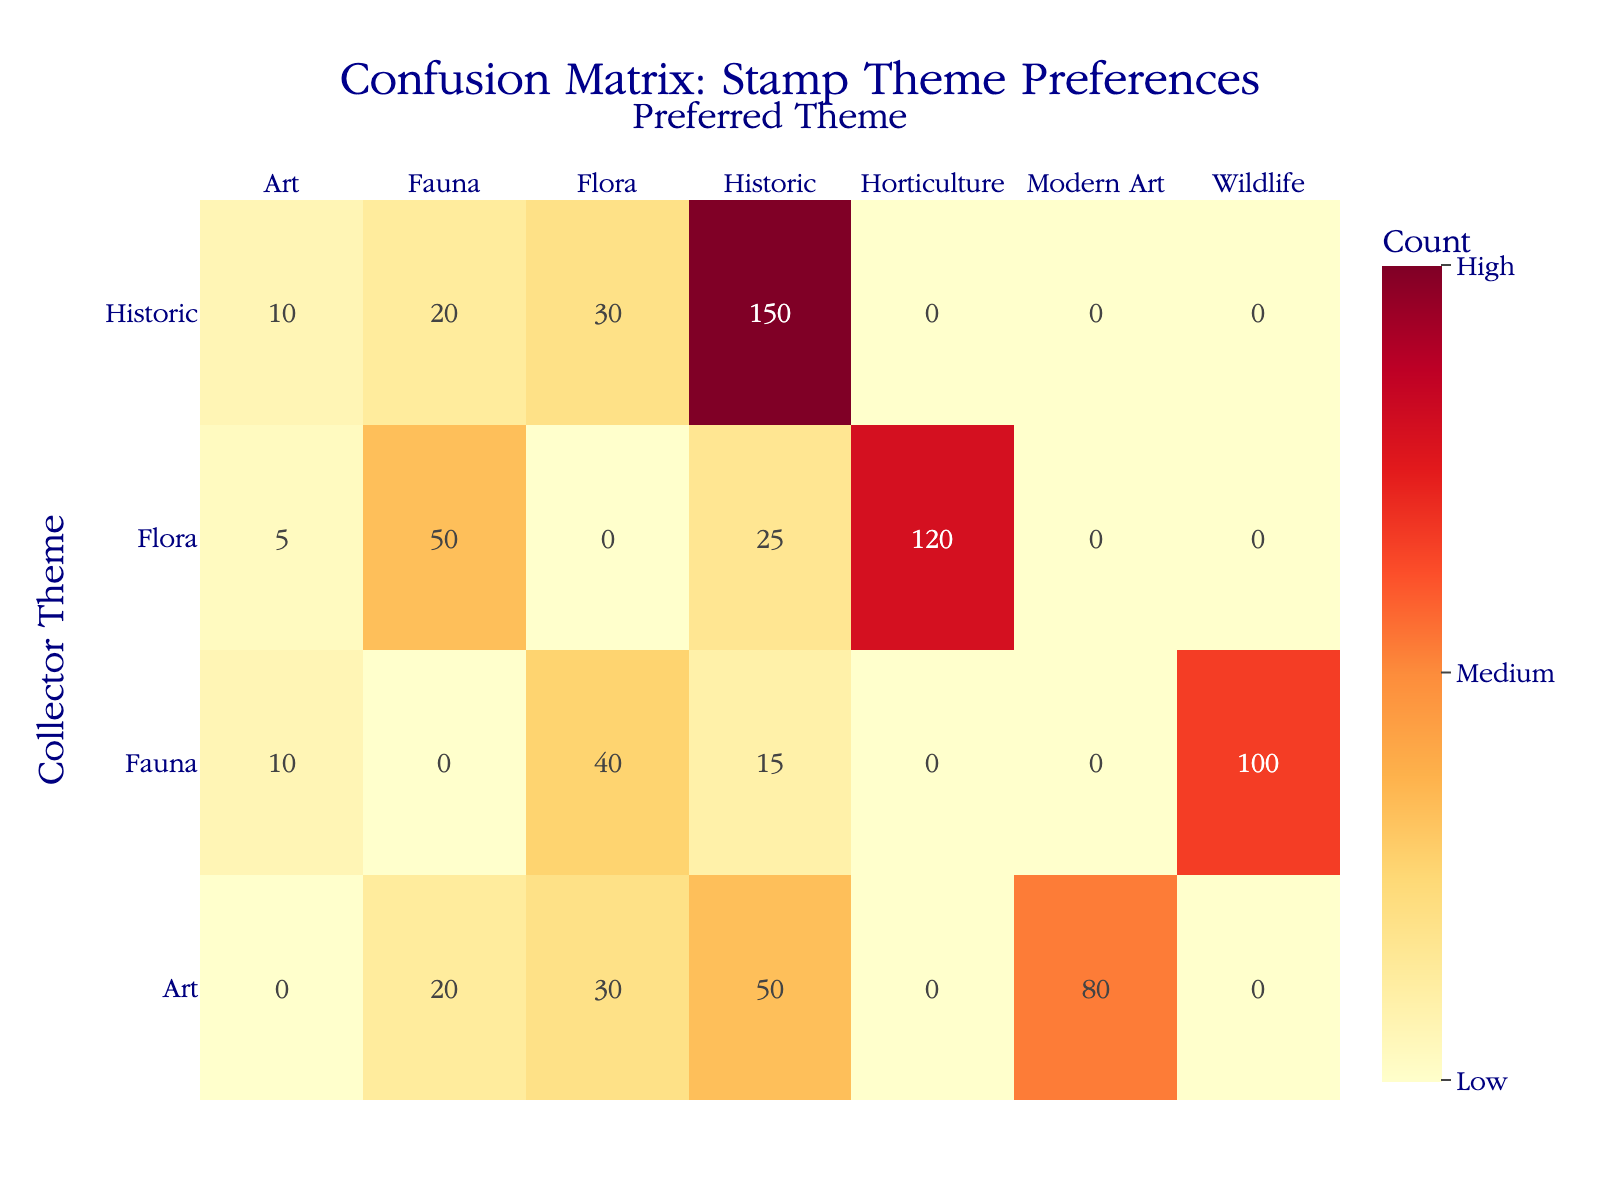What is the count of collectors preferring Historic themes from those who collected Fauna? The table shows that 15 collectors who prefer Historic themes are part of the Fauna category.
Answer: 15 Which Preferred Theme has the highest count among collectors who prefer Flora? From the table, Horticulture is the Preferred Theme with a count of 120 among the Flora collectors.
Answer: Horticulture How many collectors prefer Art themes in total? The counts for Art themes from the table are: 80 (Modern Art) + 50 (Historic) + 30 (Flora) + 20 (Fauna) = 180 collectors.
Answer: 180 Is Historical the least liked Preferred Theme among collectors who prefer Fauna? The counts for Fauna preferences show 15 for Historic, which is lower than 40 (Flora) and 100 (Wildlife), confirming that Historic is indeed the least liked.
Answer: Yes What is the difference in popularity between the Preferred Theme of Horticulture and the Preferred Theme of Wildlife? From the table, Horticulture has a count of 120, while Wildlife has a count of 100. The difference in popularity is 120 - 100 = 20.
Answer: 20 What percentage of collectors that prefer Flora also prefer Art? The total for collectors preferring Flora is 120 + 25 + 50 + 5 = 200. The counts for those preferring Art among Flora collectors is 5. The percentage is (5/200) * 100 = 2.5%.
Answer: 2.5% Which collector theme is preferred the most by collectors who also choose Historic themes? The table indicates that Historic has the highest count of 150 for those who prefer Historic themes, making it the most preferred.
Answer: Historic How many total collectors participated in the survey for Historic, Flora, Fauna, and Art themes? The total can be calculated as follows: 150 (Historic) + 30 + 20 + 10 (Flora as Historic) + 120 + 25 + 50 + 5 (Flora preferences) + 100 + 40 + 15 + 10 (Fauna preferences) + 80 + 50 + 30 + 20 (Art preferences). The overall total is 150 + 30 + 20 + 10 + 120 + 25 + 50 + 5 + 100 + 40 + 15 + 10 + 80 + 50 + 30 + 20 = 610.
Answer: 610 Is there a greater number of collectors preferring Flora compared to those preferring Fauna? The counts show 200 collectors prefer Flora (adding 120 for Horticulture, 25, 50, and 5) compared to 265 preferring Fauna (adding 100, 40, 15, and 10). Therefore, there are more collectors preferring Fauna than Flora.
Answer: No 